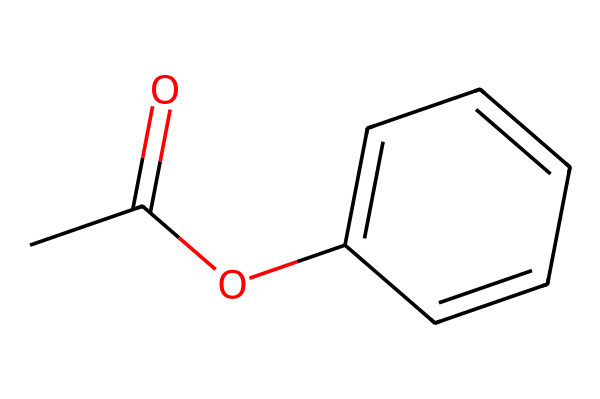how many carbon atoms are in the structure? By analyzing the SMILES notation CC(=O)OC1=CC=CC=C1, we see three carbon atoms represented in the acetyl group (CC(=O)) and six in the aromatic ring (C1=CC=CC=C1), totaling nine carbon atoms.
Answer: nine what type of functional group is present in this compound? The functional group indicated by the notation CC(=O) is an acetyl group, which is characterized by a carbonyl (C=O) and a methyl group (CH3).
Answer: acetyl how many double bonds are present? In the structure, there are two types of bonds: a double bond in the carbonyl and three double bonds in the aromatic ring. Thus, there are four double bonds in total.
Answer: four what is the likely color of this dye? Dyes that are based on aromatic structures, such as the one represented by this SMILES notation, typically produce intense colors. Thus, it is likely that this dye will have a vibrant color often seen in wood stains.
Answer: vibrant is this dye water-soluble? The presence of the acetyl group tends to improve solubility in organic solvents while the aromatic rings may not be highly polar. Therefore, it is likely soluble in organic solvents but not in water.
Answer: no what category of dyes does this compound belong to? This compound, having an aromatic structure along with an acetyl group, can be classified as an azo dye if it contains nitrogen. However, since it lacks a nitrogen atom in this structure, it may be categorized under direct or reactive dyes.
Answer: direct how does this dye interact with wood? The dye can interact with wood via adsorption due to the hydrophobic nature of the aromatic components, allowing it to penetrate and bind with the cellulose in wood fibers.
Answer: adsorption 